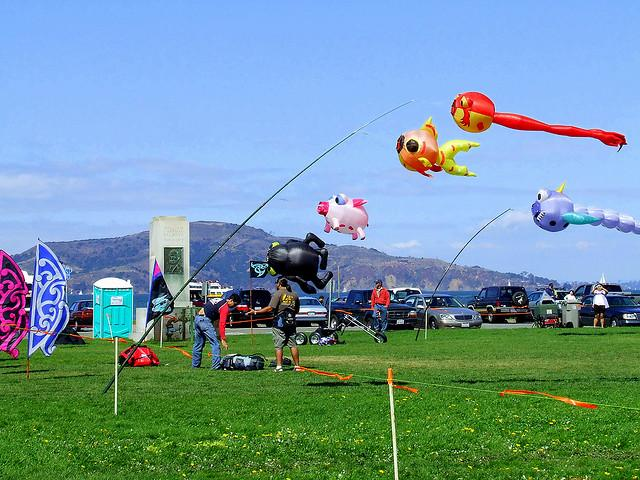Where can you reasonably go to the bathroom here?

Choices:
A) behind tree
B) male restroom
C) outhouse
D) female restroom outhouse 